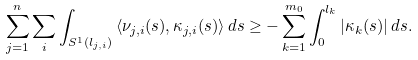<formula> <loc_0><loc_0><loc_500><loc_500>\sum _ { j = 1 } ^ { n } \sum _ { i } \int _ { S ^ { 1 } ( l _ { j , i } ) } \left \langle \nu _ { j , i } ( s ) , \kappa _ { j , i } ( s ) \right \rangle d s \geq - \sum _ { k = 1 } ^ { m _ { 0 } } \int _ { 0 } ^ { l _ { k } } \left | \kappa _ { k } ( s ) \right | d s .</formula> 